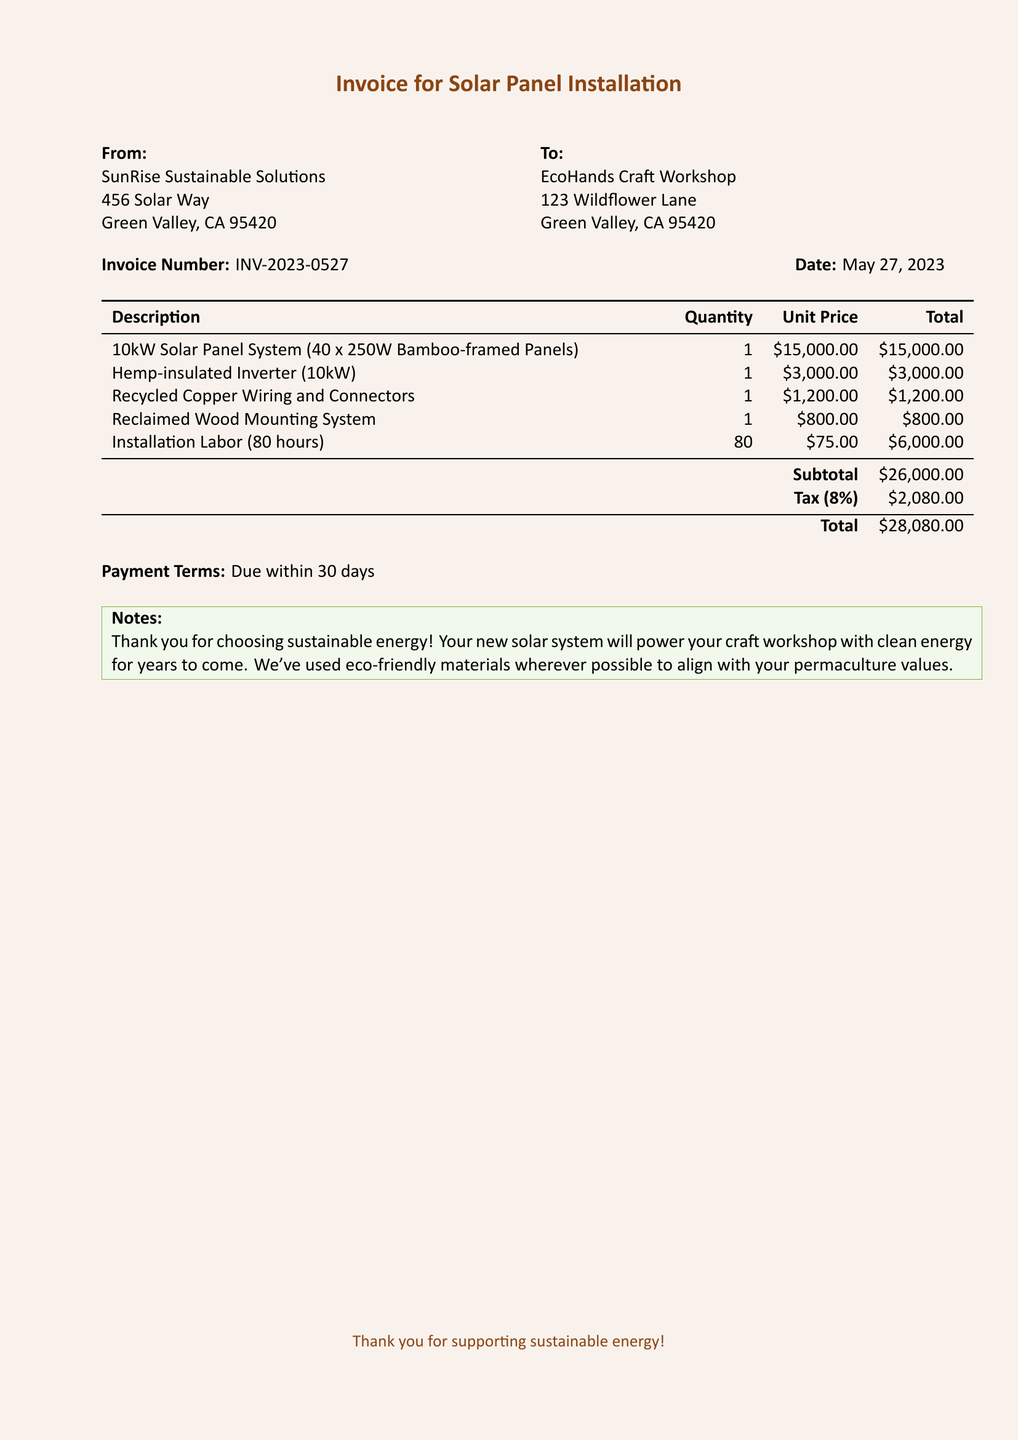What is the invoice number? The invoice number is clearly stated in the document, making it easy to identify.
Answer: INV-2023-0527 What is the date of the invoice? The date is mentioned right after the invoice number, providing important contextual information.
Answer: May 27, 2023 What is the total amount due? The total amount due is highlighted at the bottom of the itemized bill for clarity.
Answer: $28,080.00 How many solar panels are included in the system? The breakdown in the description specifies the quantity of solar panels included in the system.
Answer: 40 What is the unit price of the Hemp-insulated Inverter? The unit price is shown alongside the description and quantity for easy reference.
Answer: $3,000.00 What is the tax percentage applied to the invoice? The tax percentage is indicated clearly in the subtotal section of the invoice.
Answer: 8% What type of materials were used for the solar panel system? The notes section explicitly states that eco-friendly materials were used, aligning with sustainable values.
Answer: Eco-friendly materials How many hours of installation labor were included? The labor section lists the number of hours dedicated to the installation, important for understanding the service provided.
Answer: 80 hours 